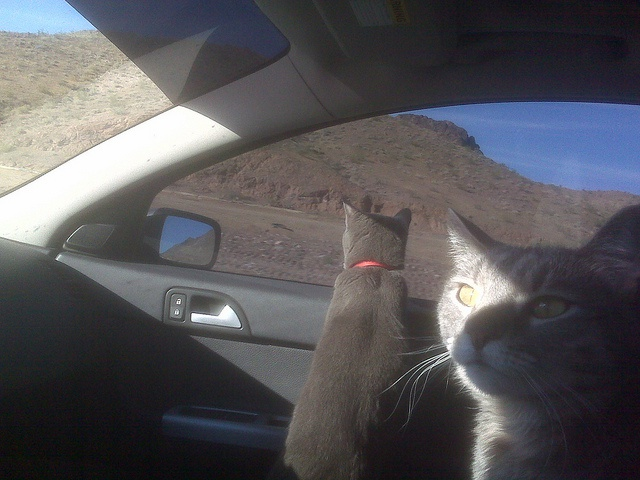Describe the objects in this image and their specific colors. I can see car in lightblue, gray, black, white, and darkgray tones, cat in lightblue, black, gray, lightgray, and darkgray tones, and cat in lightblue, gray, and black tones in this image. 